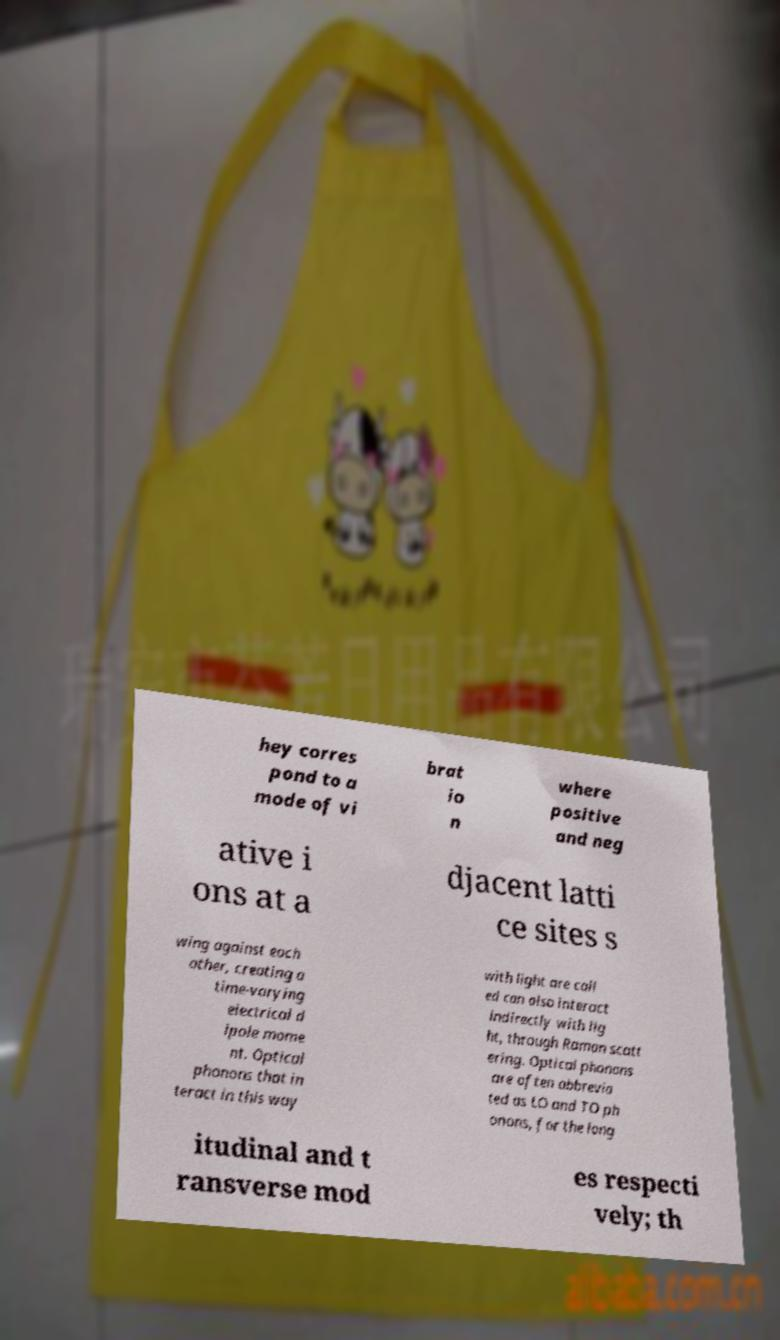There's text embedded in this image that I need extracted. Can you transcribe it verbatim? hey corres pond to a mode of vi brat io n where positive and neg ative i ons at a djacent latti ce sites s wing against each other, creating a time-varying electrical d ipole mome nt. Optical phonons that in teract in this way with light are call ed can also interact indirectly with lig ht, through Raman scatt ering. Optical phonons are often abbrevia ted as LO and TO ph onons, for the long itudinal and t ransverse mod es respecti vely; th 